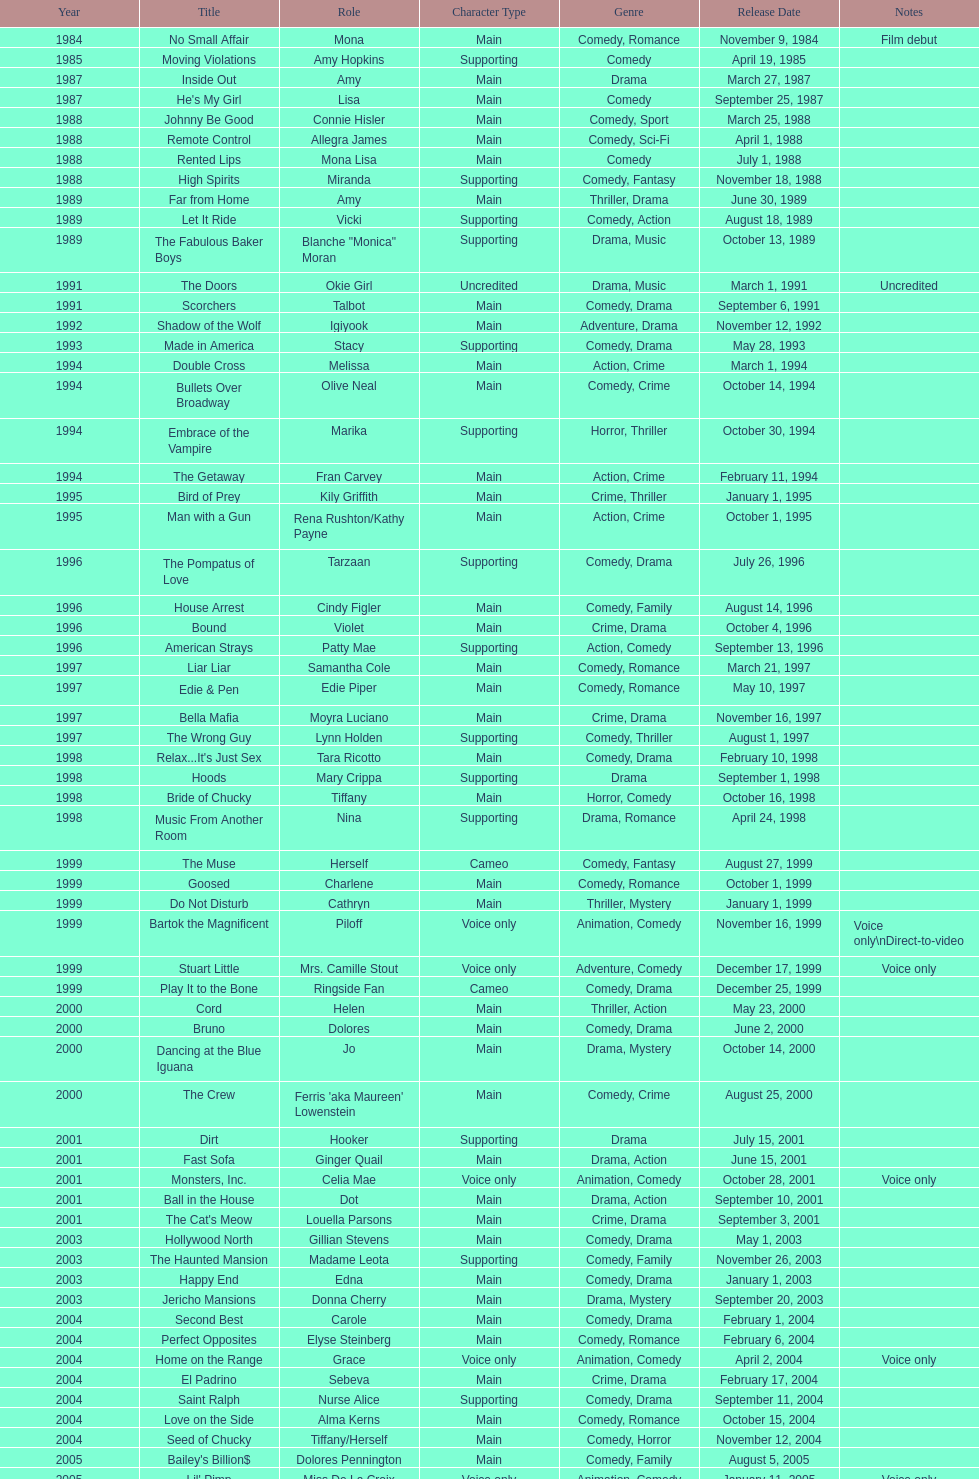Which year had the most credits? 2004. 